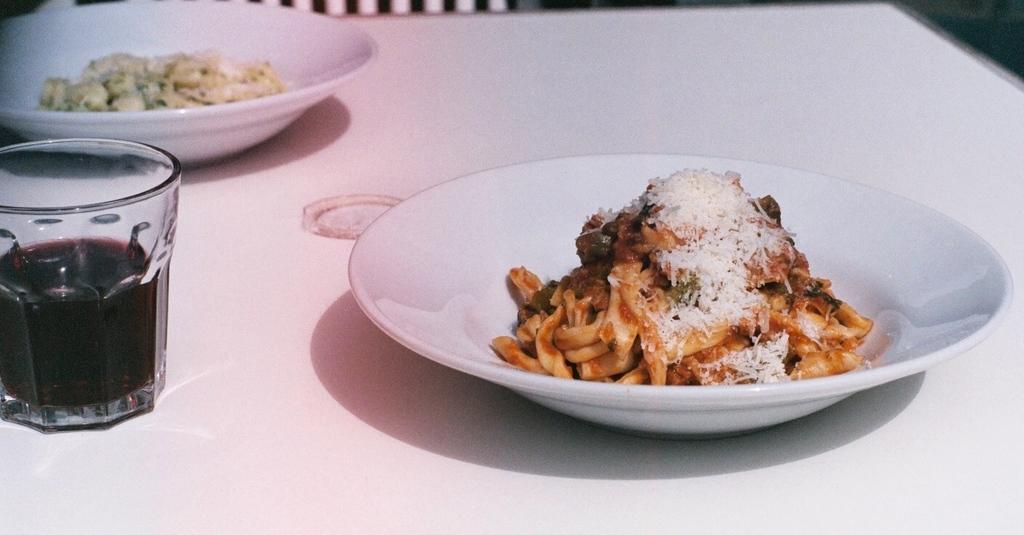Could you give a brief overview of what you see in this image? In this picture there is food in the white plate. Beside there is a wine glass, which is placed on the white color table top. 